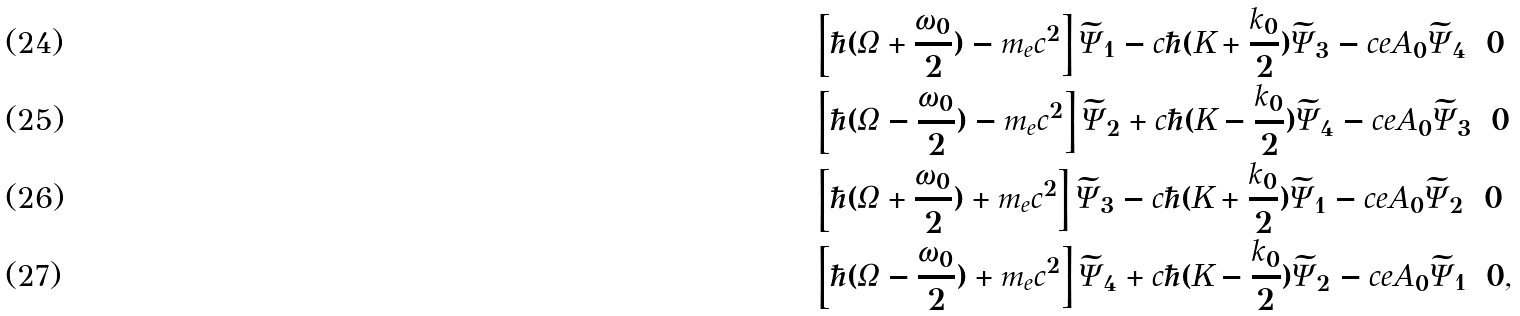<formula> <loc_0><loc_0><loc_500><loc_500>& \left [ \hbar { ( } \Omega + \frac { \omega _ { 0 } } { 2 } ) - m _ { e } c ^ { 2 } \right ] \widetilde { \Psi } _ { 1 } - c \hbar { ( } K + \frac { k _ { 0 } } { 2 } ) \widetilde { \Psi } _ { 3 } - c e A _ { 0 } \widetilde { \Psi } _ { 4 } = 0 \\ & \left [ \hbar { ( } \Omega - \frac { \omega _ { 0 } } { 2 } ) - m _ { e } c ^ { 2 } \right ] \widetilde { \Psi } _ { 2 } + c \hbar { ( } K - \frac { k _ { 0 } } { 2 } ) \widetilde { \Psi } _ { 4 } - c e A _ { 0 } \widetilde { \Psi } _ { 3 } = 0 \\ & \left [ \hbar { ( } \Omega + \frac { \omega _ { 0 } } { 2 } ) + m _ { e } c ^ { 2 } \right ] \widetilde { \Psi } _ { 3 } - c \hbar { ( } K + \frac { k _ { 0 } } { 2 } ) \widetilde { \Psi } _ { 1 } - c e A _ { 0 } \widetilde { \Psi } _ { 2 } = 0 \\ & \left [ \hbar { ( } \Omega - \frac { \omega _ { 0 } } { 2 } ) + m _ { e } c ^ { 2 } \right ] \widetilde { \Psi } _ { 4 } + c \hbar { ( } K - \frac { k _ { 0 } } { 2 } ) \widetilde { \Psi } _ { 2 } - c e A _ { 0 } \widetilde { \Psi } _ { 1 } = 0 ,</formula> 